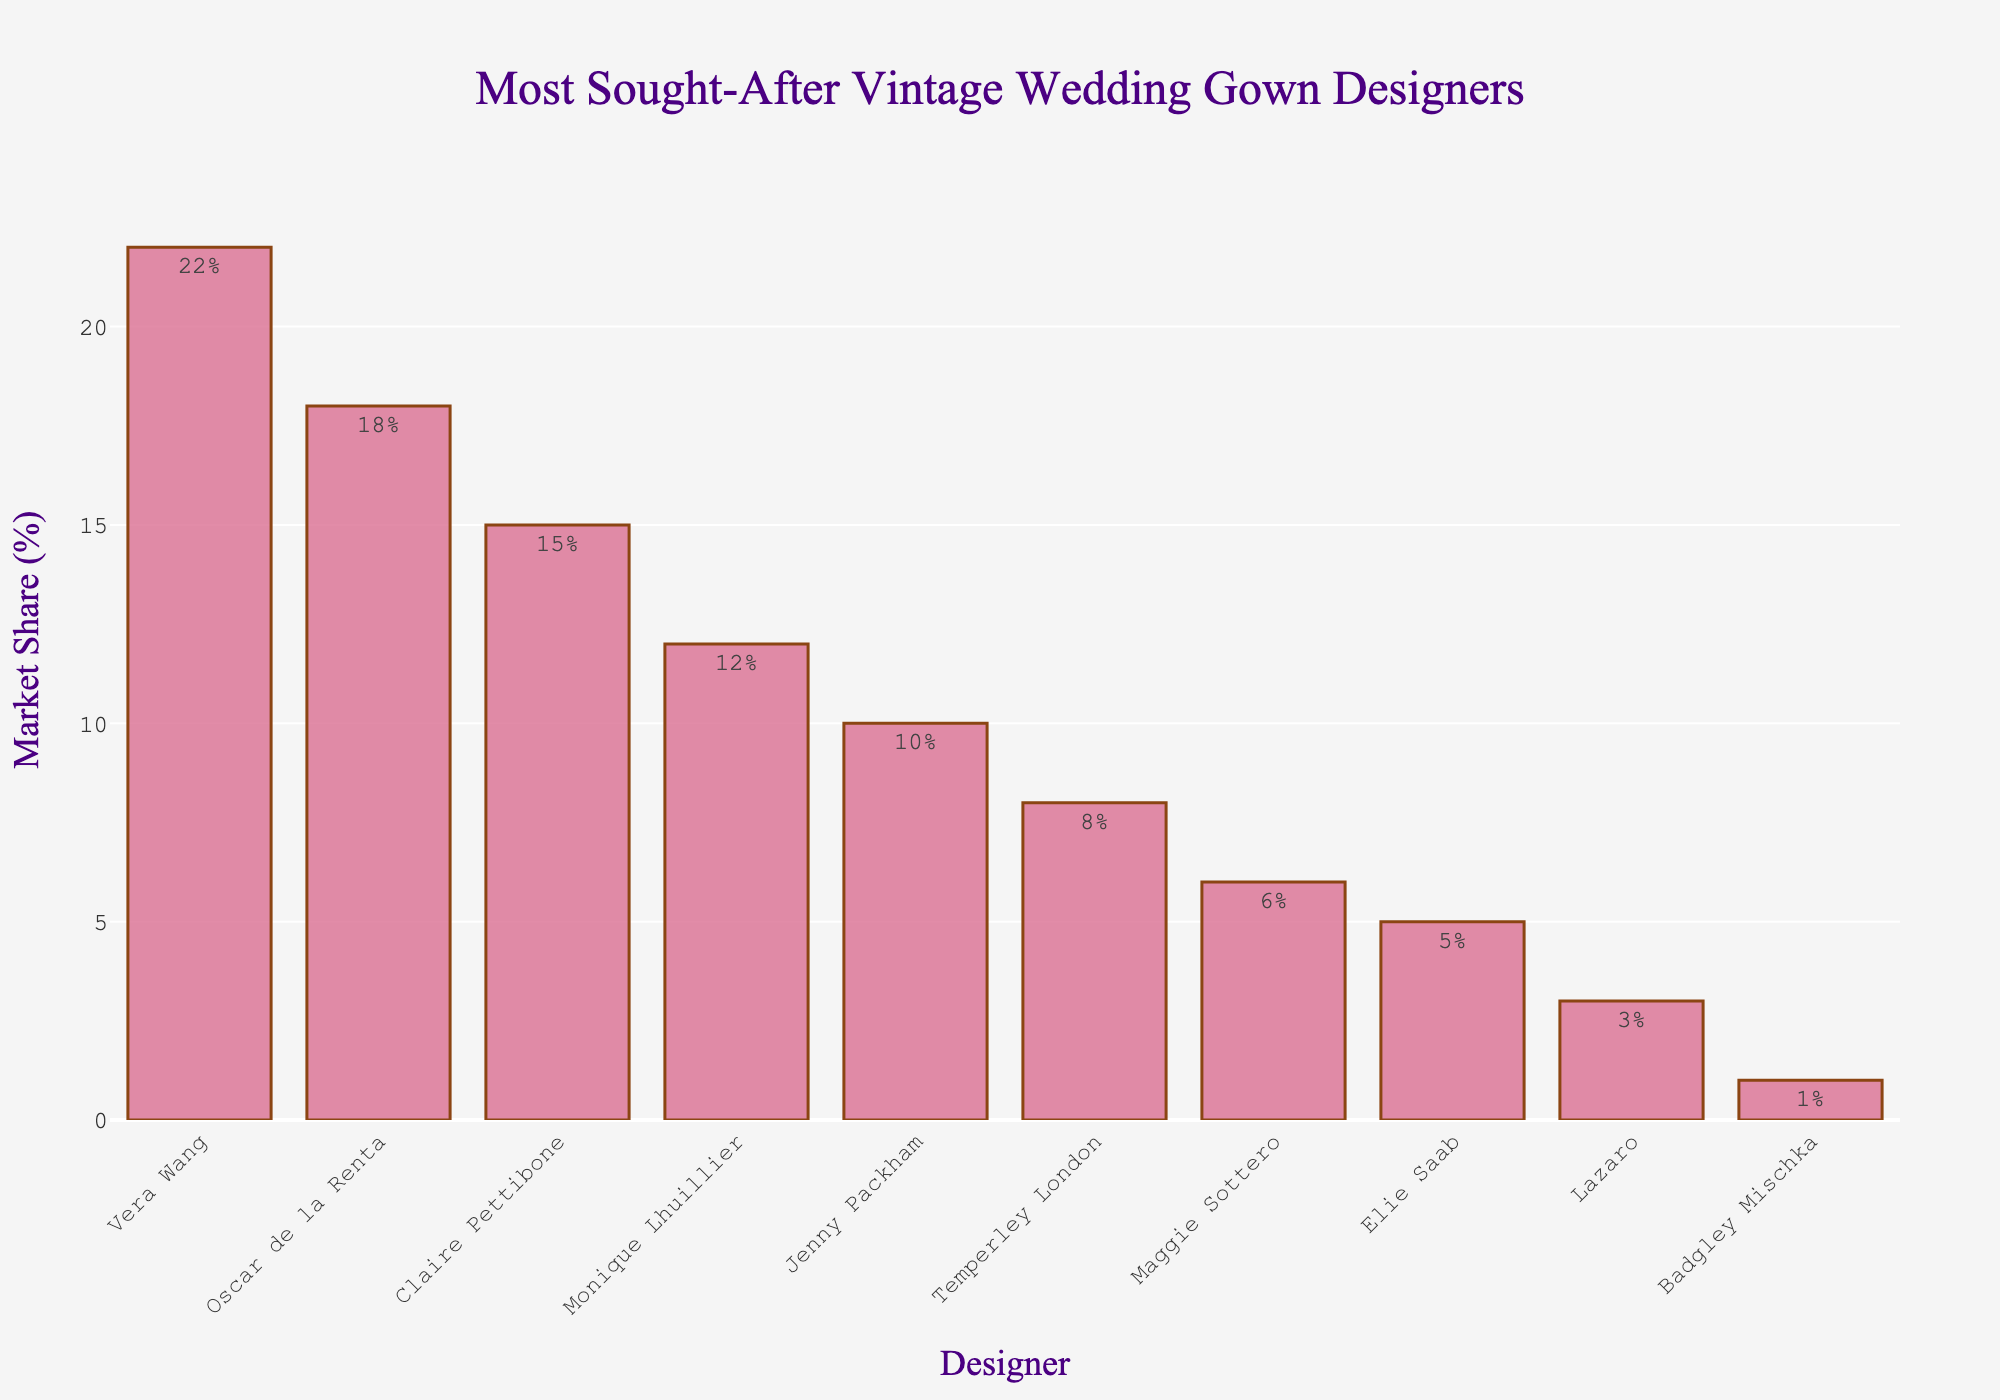What is the market share difference between Vera Wang and Oscar de la Renta? The bar representing Vera Wang reaches 22% while the bar for Oscar de la Renta reaches 18%. Calculate the difference: 22% - 18%.
Answer: 4% Which designer has the smallest market share? The shortest bar corresponds to the smallest market share. The shortest bar belongs to Badgley Mischka, with a market share of 1%.
Answer: Badgley Mischka What is the total market share of Monique Lhuillier, Jenny Packham, and Temperley London combined? Find the bars for Monique Lhuillier (12%), Jenny Packham (10%), and Temperley London (8%). Sum them up: 12% + 10% + 8%.
Answer: 30% How much higher is Vera Wang's market share compared to Maggie Sottero's? Vera Wang's market share is 22%, and Maggie Sottero's market share is 6%. Subtract the smaller from the larger: 22% - 6%.
Answer: 16% Compare the market share of Elie Saab and Lazaro. Which designer's market share is higher and by how much? Elie Saab has a market share of 5%, and Lazaro has a market share of 3%. Subtract the smaller from the larger: 5% - 3%.
Answer: Elie Saab has 2% more What is the average market share of the top three designers? The top three designers by market share are Vera Wang (22%), Oscar de la Renta (18%), and Claire Pettibone (15%). Calculate the average: (22% + 18% + 15%)/3.
Answer: 18.33% Which designers have a market share between 5% and 12% inclusive? Identify bars that fall between 5% and 12%. They belong to Monique Lhuillier (12%), Jenny Packham (10%), Temperley London (8%), and Maggie Sottero (6%).
Answer: Monique Lhuillier, Jenny Packham, Temperley London, Maggie Sottero How many designers have a market share less than 10%? Count the bars with a market share less than 10%. They are Temperley London (8%), Maggie Sottero (6%), Elie Saab (5%), Lazaro (3%), and Badgley Mischka (1%).
Answer: 5 What is the median market share value for all the designers? List the market share values in ascending order: 1%, 3%, 5%, 6%, 8%, 10%, 12%, 15%, 18%, 22%. The median is the middle value when the total number is odd or the average of two middle values when even. Here, there are 10 values, so the median is the average of the 5th (8%) and 6th (10%) values: (8% + 10%)/2.
Answer: 9% 